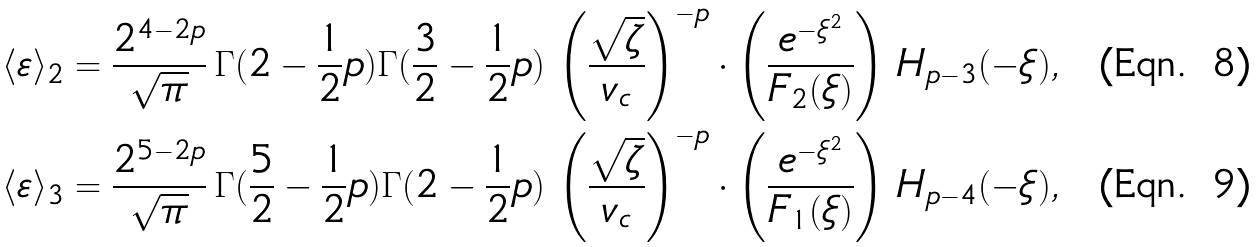Convert formula to latex. <formula><loc_0><loc_0><loc_500><loc_500>\langle \varepsilon \rangle _ { 2 } & = \frac { 2 ^ { 4 - 2 p } } { \sqrt { \pi } } \, \Gamma ( 2 - \frac { 1 } { 2 } p ) \Gamma ( \frac { 3 } { 2 } - \frac { 1 } { 2 } p ) \, \left ( \frac { \sqrt { \zeta } } { v _ { c } } \right ) ^ { - p } \cdot \left ( \frac { e ^ { - \xi ^ { 2 } } } { F _ { 2 } ( \xi ) } \right ) \, H _ { p - 3 } ( - \xi ) , \\ \langle \varepsilon \rangle _ { 3 } & = \frac { 2 ^ { 5 - 2 p } } { \sqrt { \pi } } \, \Gamma ( \frac { 5 } { 2 } - \frac { 1 } { 2 } p ) \Gamma ( 2 - \frac { 1 } { 2 } p ) \, \left ( \frac { \sqrt { \zeta } } { v _ { c } } \right ) ^ { - p } \cdot \left ( \frac { e ^ { - \xi ^ { 2 } } } { F _ { 1 } ( \xi ) } \right ) \, H _ { p - 4 } ( - \xi ) ,</formula> 